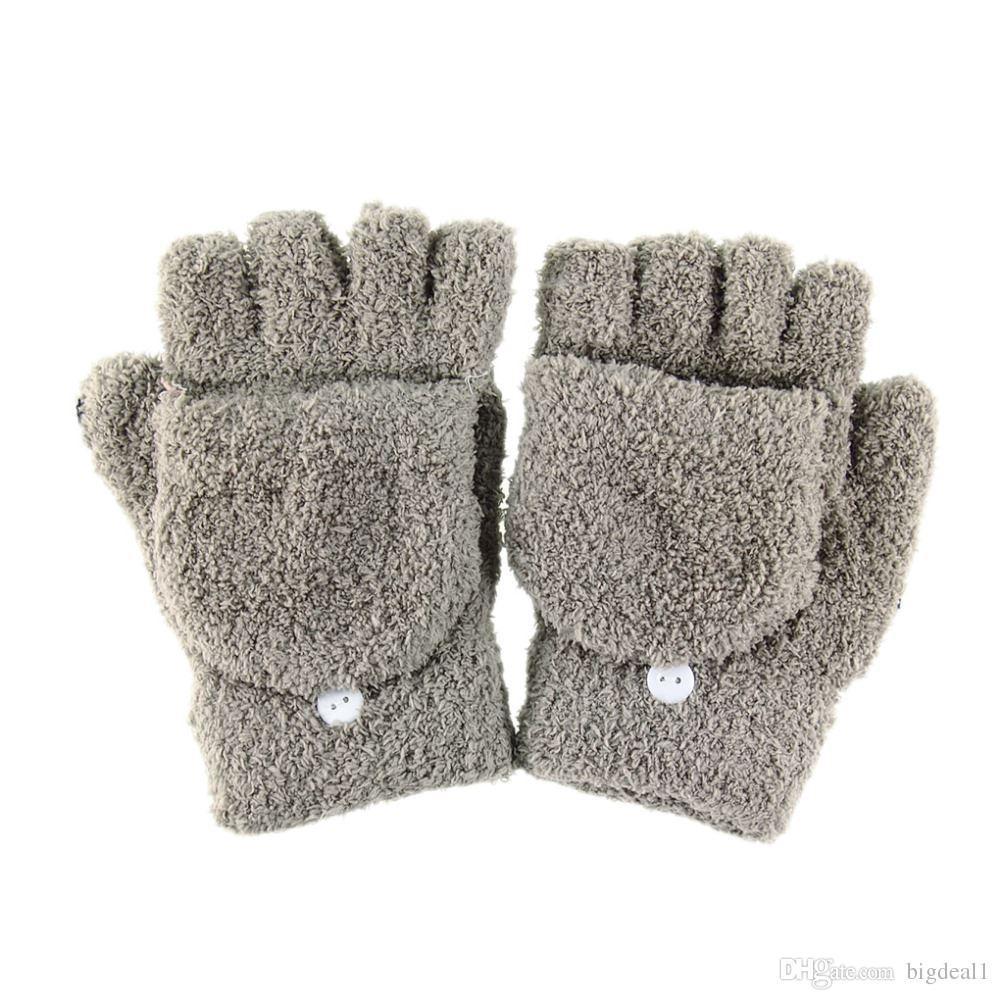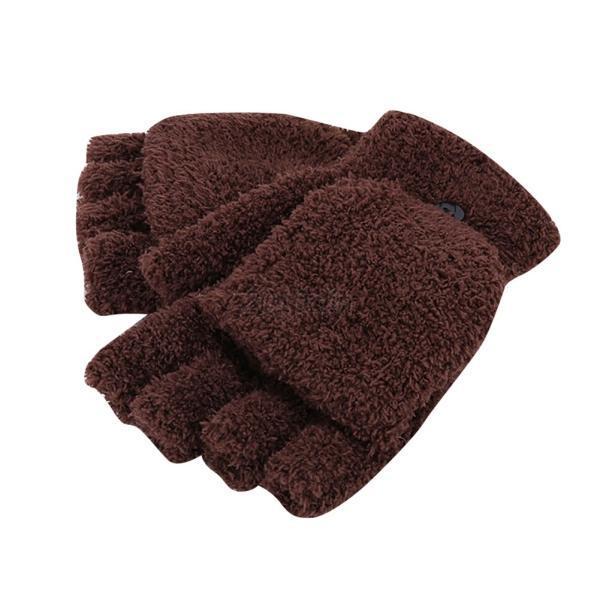The first image is the image on the left, the second image is the image on the right. For the images displayed, is the sentence "The left image shows a pair of pink half-finger gloves with a mitten flap, and the right shows the same type of fashion in heather yarn, but only one shows gloves worn by hands." factually correct? Answer yes or no. No. The first image is the image on the left, the second image is the image on the right. Assess this claim about the two images: "There is a set of pink convertible mittens in one image.". Correct or not? Answer yes or no. No. 